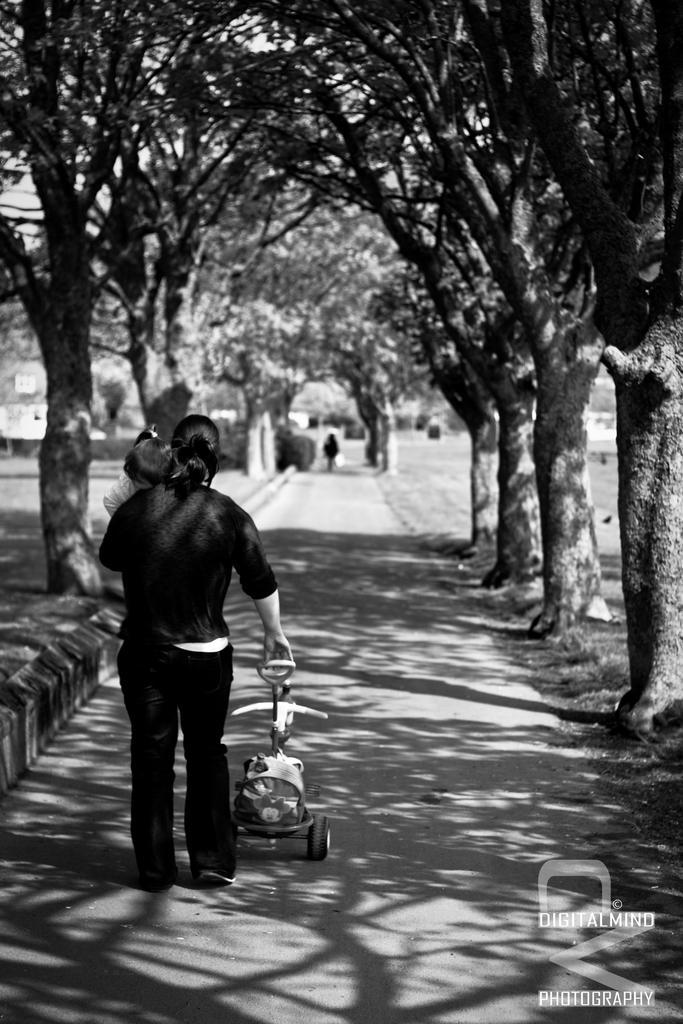How would you summarize this image in a sentence or two? This is the black and white image where we can see a person is carrying a child and the baby chair is walking on the road. Here we can see trees on the either side of the image. The background of the image is slightly blurred, where we can see a person walking. Here we can see the logo on the bottom right side of the image. 